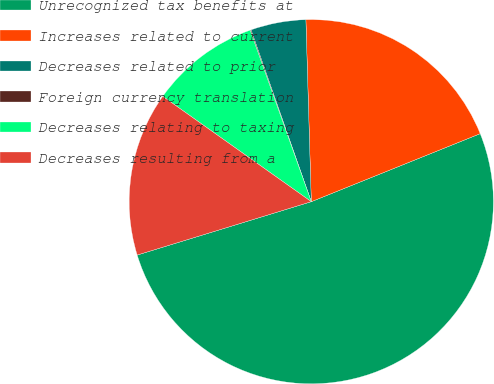Convert chart to OTSL. <chart><loc_0><loc_0><loc_500><loc_500><pie_chart><fcel>Unrecognized tax benefits at<fcel>Increases related to current<fcel>Decreases related to prior<fcel>Foreign currency translation<fcel>Decreases relating to taxing<fcel>Decreases resulting from a<nl><fcel>51.36%<fcel>19.38%<fcel>4.9%<fcel>0.08%<fcel>9.73%<fcel>14.55%<nl></chart> 